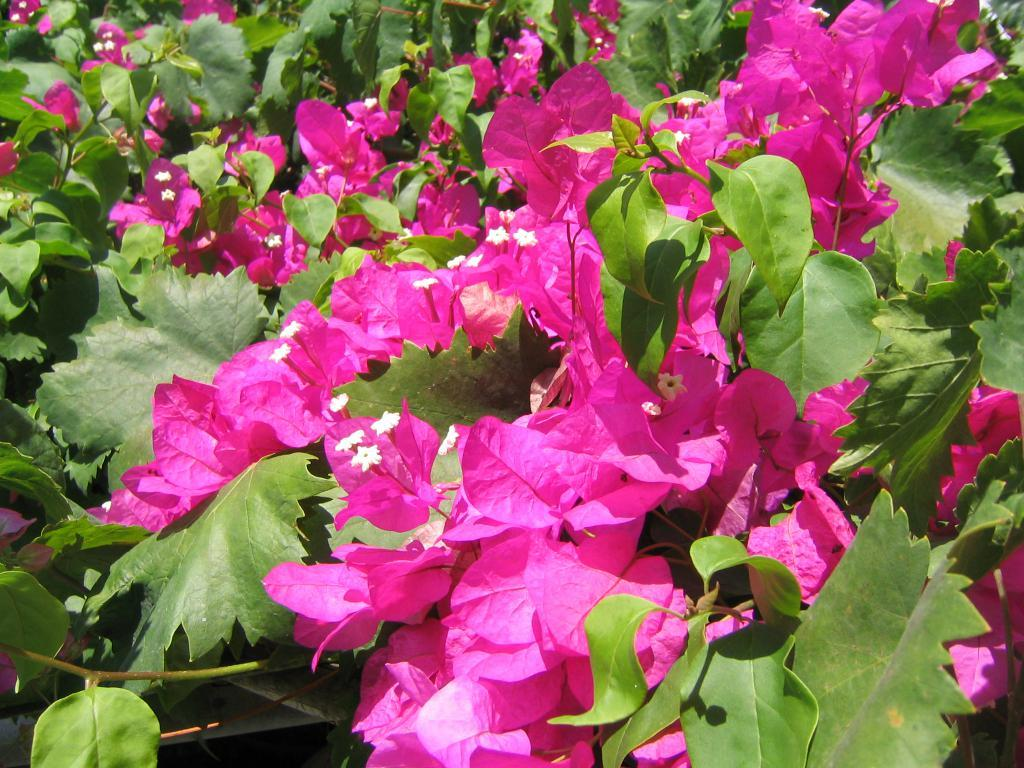What type of living organisms can be seen in the image? Plants can be seen in the image. What specific feature can be observed about the flowers among the plants? The flowers have pink leaf-like shapes. What type of food is being prepared at the seashore in the image? There is no food or seashore present in the image; it features plants with pink leaf-like flowers. 